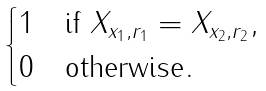Convert formula to latex. <formula><loc_0><loc_0><loc_500><loc_500>\begin{cases} 1 & \text {if $ X_{x_{1},r_{1}} = X_{x_{2},r_{2}} $} , \\ 0 & \text {otherwise} . \end{cases}</formula> 